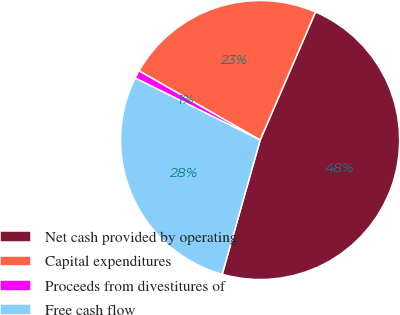<chart> <loc_0><loc_0><loc_500><loc_500><pie_chart><fcel>Net cash provided by operating<fcel>Capital expenditures<fcel>Proceeds from divestitures of<fcel>Free cash flow<nl><fcel>47.89%<fcel>23.24%<fcel>0.93%<fcel>27.94%<nl></chart> 